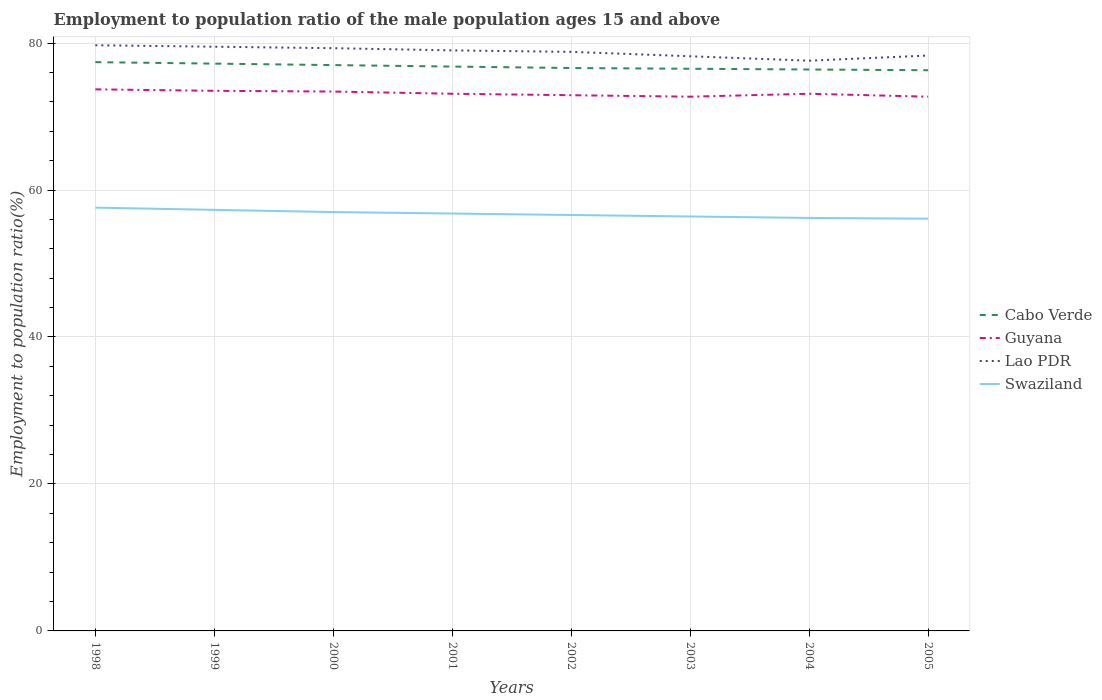Does the line corresponding to Lao PDR intersect with the line corresponding to Swaziland?
Offer a terse response. No. Across all years, what is the maximum employment to population ratio in Guyana?
Your response must be concise. 72.7. What is the total employment to population ratio in Swaziland in the graph?
Your answer should be very brief. 0.8. What is the difference between the highest and the second highest employment to population ratio in Cabo Verde?
Give a very brief answer. 1.1. How many lines are there?
Offer a terse response. 4. What is the difference between two consecutive major ticks on the Y-axis?
Your answer should be compact. 20. Are the values on the major ticks of Y-axis written in scientific E-notation?
Offer a terse response. No. Does the graph contain grids?
Provide a short and direct response. Yes. Where does the legend appear in the graph?
Ensure brevity in your answer.  Center right. How are the legend labels stacked?
Make the answer very short. Vertical. What is the title of the graph?
Offer a very short reply. Employment to population ratio of the male population ages 15 and above. Does "Liechtenstein" appear as one of the legend labels in the graph?
Provide a succinct answer. No. What is the label or title of the X-axis?
Provide a succinct answer. Years. What is the label or title of the Y-axis?
Provide a short and direct response. Employment to population ratio(%). What is the Employment to population ratio(%) in Cabo Verde in 1998?
Provide a short and direct response. 77.4. What is the Employment to population ratio(%) of Guyana in 1998?
Keep it short and to the point. 73.7. What is the Employment to population ratio(%) in Lao PDR in 1998?
Offer a terse response. 79.7. What is the Employment to population ratio(%) in Swaziland in 1998?
Your answer should be very brief. 57.6. What is the Employment to population ratio(%) of Cabo Verde in 1999?
Ensure brevity in your answer.  77.2. What is the Employment to population ratio(%) in Guyana in 1999?
Make the answer very short. 73.5. What is the Employment to population ratio(%) of Lao PDR in 1999?
Your answer should be very brief. 79.5. What is the Employment to population ratio(%) in Swaziland in 1999?
Your response must be concise. 57.3. What is the Employment to population ratio(%) in Cabo Verde in 2000?
Provide a succinct answer. 77. What is the Employment to population ratio(%) in Guyana in 2000?
Your answer should be very brief. 73.4. What is the Employment to population ratio(%) in Lao PDR in 2000?
Provide a succinct answer. 79.3. What is the Employment to population ratio(%) of Cabo Verde in 2001?
Your response must be concise. 76.8. What is the Employment to population ratio(%) of Guyana in 2001?
Keep it short and to the point. 73.1. What is the Employment to population ratio(%) in Lao PDR in 2001?
Your answer should be compact. 79. What is the Employment to population ratio(%) in Swaziland in 2001?
Your answer should be very brief. 56.8. What is the Employment to population ratio(%) in Cabo Verde in 2002?
Keep it short and to the point. 76.6. What is the Employment to population ratio(%) of Guyana in 2002?
Offer a terse response. 72.9. What is the Employment to population ratio(%) of Lao PDR in 2002?
Keep it short and to the point. 78.8. What is the Employment to population ratio(%) in Swaziland in 2002?
Provide a succinct answer. 56.6. What is the Employment to population ratio(%) in Cabo Verde in 2003?
Make the answer very short. 76.5. What is the Employment to population ratio(%) in Guyana in 2003?
Ensure brevity in your answer.  72.7. What is the Employment to population ratio(%) in Lao PDR in 2003?
Your answer should be compact. 78.2. What is the Employment to population ratio(%) of Swaziland in 2003?
Your response must be concise. 56.4. What is the Employment to population ratio(%) of Cabo Verde in 2004?
Offer a terse response. 76.4. What is the Employment to population ratio(%) of Guyana in 2004?
Offer a terse response. 73.1. What is the Employment to population ratio(%) of Lao PDR in 2004?
Offer a very short reply. 77.6. What is the Employment to population ratio(%) in Swaziland in 2004?
Your answer should be very brief. 56.2. What is the Employment to population ratio(%) of Cabo Verde in 2005?
Give a very brief answer. 76.3. What is the Employment to population ratio(%) in Guyana in 2005?
Make the answer very short. 72.7. What is the Employment to population ratio(%) of Lao PDR in 2005?
Provide a short and direct response. 78.3. What is the Employment to population ratio(%) in Swaziland in 2005?
Provide a succinct answer. 56.1. Across all years, what is the maximum Employment to population ratio(%) of Cabo Verde?
Offer a terse response. 77.4. Across all years, what is the maximum Employment to population ratio(%) of Guyana?
Ensure brevity in your answer.  73.7. Across all years, what is the maximum Employment to population ratio(%) of Lao PDR?
Provide a short and direct response. 79.7. Across all years, what is the maximum Employment to population ratio(%) in Swaziland?
Provide a short and direct response. 57.6. Across all years, what is the minimum Employment to population ratio(%) in Cabo Verde?
Offer a terse response. 76.3. Across all years, what is the minimum Employment to population ratio(%) in Guyana?
Keep it short and to the point. 72.7. Across all years, what is the minimum Employment to population ratio(%) in Lao PDR?
Ensure brevity in your answer.  77.6. Across all years, what is the minimum Employment to population ratio(%) in Swaziland?
Your response must be concise. 56.1. What is the total Employment to population ratio(%) of Cabo Verde in the graph?
Offer a very short reply. 614.2. What is the total Employment to population ratio(%) in Guyana in the graph?
Provide a succinct answer. 585.1. What is the total Employment to population ratio(%) of Lao PDR in the graph?
Provide a succinct answer. 630.4. What is the total Employment to population ratio(%) of Swaziland in the graph?
Provide a short and direct response. 454. What is the difference between the Employment to population ratio(%) of Cabo Verde in 1998 and that in 1999?
Your answer should be compact. 0.2. What is the difference between the Employment to population ratio(%) of Guyana in 1998 and that in 1999?
Offer a terse response. 0.2. What is the difference between the Employment to population ratio(%) in Lao PDR in 1998 and that in 1999?
Make the answer very short. 0.2. What is the difference between the Employment to population ratio(%) of Lao PDR in 1998 and that in 2000?
Offer a terse response. 0.4. What is the difference between the Employment to population ratio(%) in Swaziland in 1998 and that in 2000?
Provide a short and direct response. 0.6. What is the difference between the Employment to population ratio(%) in Swaziland in 1998 and that in 2002?
Keep it short and to the point. 1. What is the difference between the Employment to population ratio(%) of Guyana in 1998 and that in 2003?
Give a very brief answer. 1. What is the difference between the Employment to population ratio(%) in Guyana in 1998 and that in 2004?
Ensure brevity in your answer.  0.6. What is the difference between the Employment to population ratio(%) of Lao PDR in 1998 and that in 2004?
Your answer should be very brief. 2.1. What is the difference between the Employment to population ratio(%) in Cabo Verde in 1998 and that in 2005?
Offer a terse response. 1.1. What is the difference between the Employment to population ratio(%) of Guyana in 1998 and that in 2005?
Make the answer very short. 1. What is the difference between the Employment to population ratio(%) in Lao PDR in 1998 and that in 2005?
Your answer should be very brief. 1.4. What is the difference between the Employment to population ratio(%) in Swaziland in 1998 and that in 2005?
Offer a very short reply. 1.5. What is the difference between the Employment to population ratio(%) of Cabo Verde in 1999 and that in 2000?
Provide a short and direct response. 0.2. What is the difference between the Employment to population ratio(%) in Lao PDR in 1999 and that in 2000?
Your answer should be very brief. 0.2. What is the difference between the Employment to population ratio(%) in Cabo Verde in 1999 and that in 2001?
Make the answer very short. 0.4. What is the difference between the Employment to population ratio(%) in Cabo Verde in 1999 and that in 2003?
Ensure brevity in your answer.  0.7. What is the difference between the Employment to population ratio(%) of Lao PDR in 1999 and that in 2004?
Offer a very short reply. 1.9. What is the difference between the Employment to population ratio(%) of Swaziland in 1999 and that in 2004?
Provide a succinct answer. 1.1. What is the difference between the Employment to population ratio(%) of Guyana in 1999 and that in 2005?
Ensure brevity in your answer.  0.8. What is the difference between the Employment to population ratio(%) of Lao PDR in 1999 and that in 2005?
Provide a short and direct response. 1.2. What is the difference between the Employment to population ratio(%) in Swaziland in 1999 and that in 2005?
Keep it short and to the point. 1.2. What is the difference between the Employment to population ratio(%) in Cabo Verde in 2000 and that in 2001?
Your answer should be very brief. 0.2. What is the difference between the Employment to population ratio(%) in Cabo Verde in 2000 and that in 2002?
Keep it short and to the point. 0.4. What is the difference between the Employment to population ratio(%) in Swaziland in 2000 and that in 2002?
Keep it short and to the point. 0.4. What is the difference between the Employment to population ratio(%) of Guyana in 2000 and that in 2003?
Give a very brief answer. 0.7. What is the difference between the Employment to population ratio(%) in Cabo Verde in 2000 and that in 2004?
Provide a short and direct response. 0.6. What is the difference between the Employment to population ratio(%) of Guyana in 2000 and that in 2004?
Your answer should be very brief. 0.3. What is the difference between the Employment to population ratio(%) in Swaziland in 2000 and that in 2004?
Your answer should be very brief. 0.8. What is the difference between the Employment to population ratio(%) of Cabo Verde in 2000 and that in 2005?
Your answer should be very brief. 0.7. What is the difference between the Employment to population ratio(%) of Guyana in 2000 and that in 2005?
Offer a terse response. 0.7. What is the difference between the Employment to population ratio(%) of Swaziland in 2000 and that in 2005?
Ensure brevity in your answer.  0.9. What is the difference between the Employment to population ratio(%) of Guyana in 2001 and that in 2002?
Keep it short and to the point. 0.2. What is the difference between the Employment to population ratio(%) of Cabo Verde in 2001 and that in 2003?
Offer a terse response. 0.3. What is the difference between the Employment to population ratio(%) of Guyana in 2001 and that in 2003?
Keep it short and to the point. 0.4. What is the difference between the Employment to population ratio(%) of Lao PDR in 2001 and that in 2003?
Ensure brevity in your answer.  0.8. What is the difference between the Employment to population ratio(%) in Swaziland in 2001 and that in 2003?
Provide a short and direct response. 0.4. What is the difference between the Employment to population ratio(%) of Cabo Verde in 2001 and that in 2004?
Give a very brief answer. 0.4. What is the difference between the Employment to population ratio(%) of Cabo Verde in 2001 and that in 2005?
Provide a short and direct response. 0.5. What is the difference between the Employment to population ratio(%) in Cabo Verde in 2002 and that in 2003?
Make the answer very short. 0.1. What is the difference between the Employment to population ratio(%) in Guyana in 2002 and that in 2003?
Provide a succinct answer. 0.2. What is the difference between the Employment to population ratio(%) in Swaziland in 2002 and that in 2003?
Your answer should be compact. 0.2. What is the difference between the Employment to population ratio(%) in Cabo Verde in 2002 and that in 2005?
Your response must be concise. 0.3. What is the difference between the Employment to population ratio(%) of Lao PDR in 2002 and that in 2005?
Provide a short and direct response. 0.5. What is the difference between the Employment to population ratio(%) in Guyana in 2003 and that in 2004?
Make the answer very short. -0.4. What is the difference between the Employment to population ratio(%) of Lao PDR in 2003 and that in 2004?
Offer a very short reply. 0.6. What is the difference between the Employment to population ratio(%) in Guyana in 2003 and that in 2005?
Make the answer very short. 0. What is the difference between the Employment to population ratio(%) of Guyana in 2004 and that in 2005?
Keep it short and to the point. 0.4. What is the difference between the Employment to population ratio(%) of Swaziland in 2004 and that in 2005?
Your response must be concise. 0.1. What is the difference between the Employment to population ratio(%) in Cabo Verde in 1998 and the Employment to population ratio(%) in Swaziland in 1999?
Provide a succinct answer. 20.1. What is the difference between the Employment to population ratio(%) in Guyana in 1998 and the Employment to population ratio(%) in Lao PDR in 1999?
Give a very brief answer. -5.8. What is the difference between the Employment to population ratio(%) in Lao PDR in 1998 and the Employment to population ratio(%) in Swaziland in 1999?
Your response must be concise. 22.4. What is the difference between the Employment to population ratio(%) of Cabo Verde in 1998 and the Employment to population ratio(%) of Guyana in 2000?
Offer a very short reply. 4. What is the difference between the Employment to population ratio(%) in Cabo Verde in 1998 and the Employment to population ratio(%) in Swaziland in 2000?
Provide a short and direct response. 20.4. What is the difference between the Employment to population ratio(%) of Guyana in 1998 and the Employment to population ratio(%) of Swaziland in 2000?
Your answer should be compact. 16.7. What is the difference between the Employment to population ratio(%) of Lao PDR in 1998 and the Employment to population ratio(%) of Swaziland in 2000?
Make the answer very short. 22.7. What is the difference between the Employment to population ratio(%) in Cabo Verde in 1998 and the Employment to population ratio(%) in Guyana in 2001?
Offer a terse response. 4.3. What is the difference between the Employment to population ratio(%) of Cabo Verde in 1998 and the Employment to population ratio(%) of Swaziland in 2001?
Ensure brevity in your answer.  20.6. What is the difference between the Employment to population ratio(%) of Guyana in 1998 and the Employment to population ratio(%) of Lao PDR in 2001?
Offer a very short reply. -5.3. What is the difference between the Employment to population ratio(%) of Lao PDR in 1998 and the Employment to population ratio(%) of Swaziland in 2001?
Provide a short and direct response. 22.9. What is the difference between the Employment to population ratio(%) of Cabo Verde in 1998 and the Employment to population ratio(%) of Guyana in 2002?
Provide a short and direct response. 4.5. What is the difference between the Employment to population ratio(%) in Cabo Verde in 1998 and the Employment to population ratio(%) in Swaziland in 2002?
Your response must be concise. 20.8. What is the difference between the Employment to population ratio(%) of Lao PDR in 1998 and the Employment to population ratio(%) of Swaziland in 2002?
Provide a short and direct response. 23.1. What is the difference between the Employment to population ratio(%) in Cabo Verde in 1998 and the Employment to population ratio(%) in Guyana in 2003?
Make the answer very short. 4.7. What is the difference between the Employment to population ratio(%) in Cabo Verde in 1998 and the Employment to population ratio(%) in Lao PDR in 2003?
Provide a short and direct response. -0.8. What is the difference between the Employment to population ratio(%) of Cabo Verde in 1998 and the Employment to population ratio(%) of Swaziland in 2003?
Provide a short and direct response. 21. What is the difference between the Employment to population ratio(%) in Guyana in 1998 and the Employment to population ratio(%) in Lao PDR in 2003?
Give a very brief answer. -4.5. What is the difference between the Employment to population ratio(%) in Guyana in 1998 and the Employment to population ratio(%) in Swaziland in 2003?
Keep it short and to the point. 17.3. What is the difference between the Employment to population ratio(%) of Lao PDR in 1998 and the Employment to population ratio(%) of Swaziland in 2003?
Ensure brevity in your answer.  23.3. What is the difference between the Employment to population ratio(%) of Cabo Verde in 1998 and the Employment to population ratio(%) of Lao PDR in 2004?
Offer a terse response. -0.2. What is the difference between the Employment to population ratio(%) of Cabo Verde in 1998 and the Employment to population ratio(%) of Swaziland in 2004?
Your answer should be compact. 21.2. What is the difference between the Employment to population ratio(%) of Guyana in 1998 and the Employment to population ratio(%) of Lao PDR in 2004?
Provide a short and direct response. -3.9. What is the difference between the Employment to population ratio(%) in Guyana in 1998 and the Employment to population ratio(%) in Swaziland in 2004?
Provide a succinct answer. 17.5. What is the difference between the Employment to population ratio(%) in Cabo Verde in 1998 and the Employment to population ratio(%) in Guyana in 2005?
Your answer should be compact. 4.7. What is the difference between the Employment to population ratio(%) of Cabo Verde in 1998 and the Employment to population ratio(%) of Lao PDR in 2005?
Offer a terse response. -0.9. What is the difference between the Employment to population ratio(%) of Cabo Verde in 1998 and the Employment to population ratio(%) of Swaziland in 2005?
Your answer should be very brief. 21.3. What is the difference between the Employment to population ratio(%) in Lao PDR in 1998 and the Employment to population ratio(%) in Swaziland in 2005?
Your answer should be very brief. 23.6. What is the difference between the Employment to population ratio(%) of Cabo Verde in 1999 and the Employment to population ratio(%) of Guyana in 2000?
Give a very brief answer. 3.8. What is the difference between the Employment to population ratio(%) in Cabo Verde in 1999 and the Employment to population ratio(%) in Lao PDR in 2000?
Keep it short and to the point. -2.1. What is the difference between the Employment to population ratio(%) of Cabo Verde in 1999 and the Employment to population ratio(%) of Swaziland in 2000?
Offer a very short reply. 20.2. What is the difference between the Employment to population ratio(%) of Guyana in 1999 and the Employment to population ratio(%) of Swaziland in 2000?
Your response must be concise. 16.5. What is the difference between the Employment to population ratio(%) in Lao PDR in 1999 and the Employment to population ratio(%) in Swaziland in 2000?
Offer a very short reply. 22.5. What is the difference between the Employment to population ratio(%) of Cabo Verde in 1999 and the Employment to population ratio(%) of Swaziland in 2001?
Give a very brief answer. 20.4. What is the difference between the Employment to population ratio(%) in Guyana in 1999 and the Employment to population ratio(%) in Lao PDR in 2001?
Keep it short and to the point. -5.5. What is the difference between the Employment to population ratio(%) in Lao PDR in 1999 and the Employment to population ratio(%) in Swaziland in 2001?
Provide a succinct answer. 22.7. What is the difference between the Employment to population ratio(%) of Cabo Verde in 1999 and the Employment to population ratio(%) of Guyana in 2002?
Keep it short and to the point. 4.3. What is the difference between the Employment to population ratio(%) of Cabo Verde in 1999 and the Employment to population ratio(%) of Swaziland in 2002?
Offer a terse response. 20.6. What is the difference between the Employment to population ratio(%) of Guyana in 1999 and the Employment to population ratio(%) of Lao PDR in 2002?
Provide a short and direct response. -5.3. What is the difference between the Employment to population ratio(%) in Lao PDR in 1999 and the Employment to population ratio(%) in Swaziland in 2002?
Give a very brief answer. 22.9. What is the difference between the Employment to population ratio(%) in Cabo Verde in 1999 and the Employment to population ratio(%) in Swaziland in 2003?
Your answer should be very brief. 20.8. What is the difference between the Employment to population ratio(%) of Guyana in 1999 and the Employment to population ratio(%) of Swaziland in 2003?
Keep it short and to the point. 17.1. What is the difference between the Employment to population ratio(%) of Lao PDR in 1999 and the Employment to population ratio(%) of Swaziland in 2003?
Offer a terse response. 23.1. What is the difference between the Employment to population ratio(%) in Cabo Verde in 1999 and the Employment to population ratio(%) in Guyana in 2004?
Your answer should be very brief. 4.1. What is the difference between the Employment to population ratio(%) of Guyana in 1999 and the Employment to population ratio(%) of Swaziland in 2004?
Offer a very short reply. 17.3. What is the difference between the Employment to population ratio(%) in Lao PDR in 1999 and the Employment to population ratio(%) in Swaziland in 2004?
Your answer should be compact. 23.3. What is the difference between the Employment to population ratio(%) in Cabo Verde in 1999 and the Employment to population ratio(%) in Swaziland in 2005?
Your answer should be compact. 21.1. What is the difference between the Employment to population ratio(%) in Guyana in 1999 and the Employment to population ratio(%) in Lao PDR in 2005?
Keep it short and to the point. -4.8. What is the difference between the Employment to population ratio(%) of Guyana in 1999 and the Employment to population ratio(%) of Swaziland in 2005?
Your answer should be compact. 17.4. What is the difference between the Employment to population ratio(%) of Lao PDR in 1999 and the Employment to population ratio(%) of Swaziland in 2005?
Give a very brief answer. 23.4. What is the difference between the Employment to population ratio(%) of Cabo Verde in 2000 and the Employment to population ratio(%) of Guyana in 2001?
Offer a very short reply. 3.9. What is the difference between the Employment to population ratio(%) in Cabo Verde in 2000 and the Employment to population ratio(%) in Lao PDR in 2001?
Keep it short and to the point. -2. What is the difference between the Employment to population ratio(%) in Cabo Verde in 2000 and the Employment to population ratio(%) in Swaziland in 2001?
Give a very brief answer. 20.2. What is the difference between the Employment to population ratio(%) in Lao PDR in 2000 and the Employment to population ratio(%) in Swaziland in 2001?
Offer a terse response. 22.5. What is the difference between the Employment to population ratio(%) of Cabo Verde in 2000 and the Employment to population ratio(%) of Guyana in 2002?
Offer a terse response. 4.1. What is the difference between the Employment to population ratio(%) in Cabo Verde in 2000 and the Employment to population ratio(%) in Swaziland in 2002?
Give a very brief answer. 20.4. What is the difference between the Employment to population ratio(%) in Lao PDR in 2000 and the Employment to population ratio(%) in Swaziland in 2002?
Your answer should be compact. 22.7. What is the difference between the Employment to population ratio(%) in Cabo Verde in 2000 and the Employment to population ratio(%) in Swaziland in 2003?
Your response must be concise. 20.6. What is the difference between the Employment to population ratio(%) of Guyana in 2000 and the Employment to population ratio(%) of Lao PDR in 2003?
Offer a very short reply. -4.8. What is the difference between the Employment to population ratio(%) of Guyana in 2000 and the Employment to population ratio(%) of Swaziland in 2003?
Your answer should be very brief. 17. What is the difference between the Employment to population ratio(%) in Lao PDR in 2000 and the Employment to population ratio(%) in Swaziland in 2003?
Keep it short and to the point. 22.9. What is the difference between the Employment to population ratio(%) of Cabo Verde in 2000 and the Employment to population ratio(%) of Guyana in 2004?
Make the answer very short. 3.9. What is the difference between the Employment to population ratio(%) in Cabo Verde in 2000 and the Employment to population ratio(%) in Swaziland in 2004?
Your answer should be compact. 20.8. What is the difference between the Employment to population ratio(%) in Guyana in 2000 and the Employment to population ratio(%) in Lao PDR in 2004?
Ensure brevity in your answer.  -4.2. What is the difference between the Employment to population ratio(%) of Guyana in 2000 and the Employment to population ratio(%) of Swaziland in 2004?
Provide a short and direct response. 17.2. What is the difference between the Employment to population ratio(%) of Lao PDR in 2000 and the Employment to population ratio(%) of Swaziland in 2004?
Offer a terse response. 23.1. What is the difference between the Employment to population ratio(%) in Cabo Verde in 2000 and the Employment to population ratio(%) in Guyana in 2005?
Offer a terse response. 4.3. What is the difference between the Employment to population ratio(%) of Cabo Verde in 2000 and the Employment to population ratio(%) of Lao PDR in 2005?
Ensure brevity in your answer.  -1.3. What is the difference between the Employment to population ratio(%) of Cabo Verde in 2000 and the Employment to population ratio(%) of Swaziland in 2005?
Offer a very short reply. 20.9. What is the difference between the Employment to population ratio(%) in Guyana in 2000 and the Employment to population ratio(%) in Lao PDR in 2005?
Ensure brevity in your answer.  -4.9. What is the difference between the Employment to population ratio(%) of Guyana in 2000 and the Employment to population ratio(%) of Swaziland in 2005?
Offer a very short reply. 17.3. What is the difference between the Employment to population ratio(%) of Lao PDR in 2000 and the Employment to population ratio(%) of Swaziland in 2005?
Offer a terse response. 23.2. What is the difference between the Employment to population ratio(%) of Cabo Verde in 2001 and the Employment to population ratio(%) of Guyana in 2002?
Offer a very short reply. 3.9. What is the difference between the Employment to population ratio(%) of Cabo Verde in 2001 and the Employment to population ratio(%) of Lao PDR in 2002?
Your answer should be compact. -2. What is the difference between the Employment to population ratio(%) in Cabo Verde in 2001 and the Employment to population ratio(%) in Swaziland in 2002?
Provide a succinct answer. 20.2. What is the difference between the Employment to population ratio(%) in Lao PDR in 2001 and the Employment to population ratio(%) in Swaziland in 2002?
Give a very brief answer. 22.4. What is the difference between the Employment to population ratio(%) of Cabo Verde in 2001 and the Employment to population ratio(%) of Guyana in 2003?
Give a very brief answer. 4.1. What is the difference between the Employment to population ratio(%) of Cabo Verde in 2001 and the Employment to population ratio(%) of Swaziland in 2003?
Give a very brief answer. 20.4. What is the difference between the Employment to population ratio(%) of Guyana in 2001 and the Employment to population ratio(%) of Swaziland in 2003?
Make the answer very short. 16.7. What is the difference between the Employment to population ratio(%) of Lao PDR in 2001 and the Employment to population ratio(%) of Swaziland in 2003?
Give a very brief answer. 22.6. What is the difference between the Employment to population ratio(%) in Cabo Verde in 2001 and the Employment to population ratio(%) in Lao PDR in 2004?
Offer a very short reply. -0.8. What is the difference between the Employment to population ratio(%) in Cabo Verde in 2001 and the Employment to population ratio(%) in Swaziland in 2004?
Your answer should be very brief. 20.6. What is the difference between the Employment to population ratio(%) of Guyana in 2001 and the Employment to population ratio(%) of Lao PDR in 2004?
Provide a succinct answer. -4.5. What is the difference between the Employment to population ratio(%) of Guyana in 2001 and the Employment to population ratio(%) of Swaziland in 2004?
Your answer should be very brief. 16.9. What is the difference between the Employment to population ratio(%) of Lao PDR in 2001 and the Employment to population ratio(%) of Swaziland in 2004?
Offer a terse response. 22.8. What is the difference between the Employment to population ratio(%) of Cabo Verde in 2001 and the Employment to population ratio(%) of Guyana in 2005?
Make the answer very short. 4.1. What is the difference between the Employment to population ratio(%) of Cabo Verde in 2001 and the Employment to population ratio(%) of Swaziland in 2005?
Provide a succinct answer. 20.7. What is the difference between the Employment to population ratio(%) of Lao PDR in 2001 and the Employment to population ratio(%) of Swaziland in 2005?
Give a very brief answer. 22.9. What is the difference between the Employment to population ratio(%) of Cabo Verde in 2002 and the Employment to population ratio(%) of Swaziland in 2003?
Offer a terse response. 20.2. What is the difference between the Employment to population ratio(%) of Guyana in 2002 and the Employment to population ratio(%) of Lao PDR in 2003?
Offer a very short reply. -5.3. What is the difference between the Employment to population ratio(%) in Guyana in 2002 and the Employment to population ratio(%) in Swaziland in 2003?
Your response must be concise. 16.5. What is the difference between the Employment to population ratio(%) in Lao PDR in 2002 and the Employment to population ratio(%) in Swaziland in 2003?
Your response must be concise. 22.4. What is the difference between the Employment to population ratio(%) in Cabo Verde in 2002 and the Employment to population ratio(%) in Lao PDR in 2004?
Your answer should be compact. -1. What is the difference between the Employment to population ratio(%) in Cabo Verde in 2002 and the Employment to population ratio(%) in Swaziland in 2004?
Your answer should be very brief. 20.4. What is the difference between the Employment to population ratio(%) in Guyana in 2002 and the Employment to population ratio(%) in Swaziland in 2004?
Provide a short and direct response. 16.7. What is the difference between the Employment to population ratio(%) in Lao PDR in 2002 and the Employment to population ratio(%) in Swaziland in 2004?
Ensure brevity in your answer.  22.6. What is the difference between the Employment to population ratio(%) of Cabo Verde in 2002 and the Employment to population ratio(%) of Guyana in 2005?
Your answer should be compact. 3.9. What is the difference between the Employment to population ratio(%) in Cabo Verde in 2002 and the Employment to population ratio(%) in Lao PDR in 2005?
Your response must be concise. -1.7. What is the difference between the Employment to population ratio(%) in Cabo Verde in 2002 and the Employment to population ratio(%) in Swaziland in 2005?
Ensure brevity in your answer.  20.5. What is the difference between the Employment to population ratio(%) in Lao PDR in 2002 and the Employment to population ratio(%) in Swaziland in 2005?
Keep it short and to the point. 22.7. What is the difference between the Employment to population ratio(%) in Cabo Verde in 2003 and the Employment to population ratio(%) in Guyana in 2004?
Offer a very short reply. 3.4. What is the difference between the Employment to population ratio(%) in Cabo Verde in 2003 and the Employment to population ratio(%) in Lao PDR in 2004?
Ensure brevity in your answer.  -1.1. What is the difference between the Employment to population ratio(%) of Cabo Verde in 2003 and the Employment to population ratio(%) of Swaziland in 2004?
Give a very brief answer. 20.3. What is the difference between the Employment to population ratio(%) in Guyana in 2003 and the Employment to population ratio(%) in Lao PDR in 2004?
Keep it short and to the point. -4.9. What is the difference between the Employment to population ratio(%) in Guyana in 2003 and the Employment to population ratio(%) in Swaziland in 2004?
Keep it short and to the point. 16.5. What is the difference between the Employment to population ratio(%) of Lao PDR in 2003 and the Employment to population ratio(%) of Swaziland in 2004?
Provide a succinct answer. 22. What is the difference between the Employment to population ratio(%) of Cabo Verde in 2003 and the Employment to population ratio(%) of Guyana in 2005?
Provide a short and direct response. 3.8. What is the difference between the Employment to population ratio(%) in Cabo Verde in 2003 and the Employment to population ratio(%) in Lao PDR in 2005?
Provide a succinct answer. -1.8. What is the difference between the Employment to population ratio(%) in Cabo Verde in 2003 and the Employment to population ratio(%) in Swaziland in 2005?
Make the answer very short. 20.4. What is the difference between the Employment to population ratio(%) in Lao PDR in 2003 and the Employment to population ratio(%) in Swaziland in 2005?
Your answer should be compact. 22.1. What is the difference between the Employment to population ratio(%) of Cabo Verde in 2004 and the Employment to population ratio(%) of Swaziland in 2005?
Make the answer very short. 20.3. What is the difference between the Employment to population ratio(%) in Lao PDR in 2004 and the Employment to population ratio(%) in Swaziland in 2005?
Provide a short and direct response. 21.5. What is the average Employment to population ratio(%) in Cabo Verde per year?
Offer a terse response. 76.78. What is the average Employment to population ratio(%) in Guyana per year?
Offer a terse response. 73.14. What is the average Employment to population ratio(%) in Lao PDR per year?
Give a very brief answer. 78.8. What is the average Employment to population ratio(%) of Swaziland per year?
Give a very brief answer. 56.75. In the year 1998, what is the difference between the Employment to population ratio(%) in Cabo Verde and Employment to population ratio(%) in Lao PDR?
Your answer should be very brief. -2.3. In the year 1998, what is the difference between the Employment to population ratio(%) of Cabo Verde and Employment to population ratio(%) of Swaziland?
Make the answer very short. 19.8. In the year 1998, what is the difference between the Employment to population ratio(%) in Guyana and Employment to population ratio(%) in Lao PDR?
Keep it short and to the point. -6. In the year 1998, what is the difference between the Employment to population ratio(%) in Guyana and Employment to population ratio(%) in Swaziland?
Offer a very short reply. 16.1. In the year 1998, what is the difference between the Employment to population ratio(%) of Lao PDR and Employment to population ratio(%) of Swaziland?
Provide a succinct answer. 22.1. In the year 1999, what is the difference between the Employment to population ratio(%) of Cabo Verde and Employment to population ratio(%) of Lao PDR?
Ensure brevity in your answer.  -2.3. In the year 1999, what is the difference between the Employment to population ratio(%) in Cabo Verde and Employment to population ratio(%) in Swaziland?
Provide a succinct answer. 19.9. In the year 1999, what is the difference between the Employment to population ratio(%) of Guyana and Employment to population ratio(%) of Swaziland?
Provide a succinct answer. 16.2. In the year 1999, what is the difference between the Employment to population ratio(%) of Lao PDR and Employment to population ratio(%) of Swaziland?
Offer a terse response. 22.2. In the year 2000, what is the difference between the Employment to population ratio(%) in Cabo Verde and Employment to population ratio(%) in Swaziland?
Give a very brief answer. 20. In the year 2000, what is the difference between the Employment to population ratio(%) of Guyana and Employment to population ratio(%) of Lao PDR?
Offer a terse response. -5.9. In the year 2000, what is the difference between the Employment to population ratio(%) of Guyana and Employment to population ratio(%) of Swaziland?
Give a very brief answer. 16.4. In the year 2000, what is the difference between the Employment to population ratio(%) in Lao PDR and Employment to population ratio(%) in Swaziland?
Offer a very short reply. 22.3. In the year 2001, what is the difference between the Employment to population ratio(%) of Cabo Verde and Employment to population ratio(%) of Guyana?
Offer a terse response. 3.7. In the year 2001, what is the difference between the Employment to population ratio(%) in Cabo Verde and Employment to population ratio(%) in Lao PDR?
Your answer should be very brief. -2.2. In the year 2001, what is the difference between the Employment to population ratio(%) in Cabo Verde and Employment to population ratio(%) in Swaziland?
Keep it short and to the point. 20. In the year 2001, what is the difference between the Employment to population ratio(%) of Guyana and Employment to population ratio(%) of Lao PDR?
Provide a short and direct response. -5.9. In the year 2002, what is the difference between the Employment to population ratio(%) in Cabo Verde and Employment to population ratio(%) in Guyana?
Give a very brief answer. 3.7. In the year 2002, what is the difference between the Employment to population ratio(%) in Cabo Verde and Employment to population ratio(%) in Swaziland?
Provide a short and direct response. 20. In the year 2002, what is the difference between the Employment to population ratio(%) of Guyana and Employment to population ratio(%) of Lao PDR?
Make the answer very short. -5.9. In the year 2002, what is the difference between the Employment to population ratio(%) of Guyana and Employment to population ratio(%) of Swaziland?
Make the answer very short. 16.3. In the year 2002, what is the difference between the Employment to population ratio(%) of Lao PDR and Employment to population ratio(%) of Swaziland?
Make the answer very short. 22.2. In the year 2003, what is the difference between the Employment to population ratio(%) of Cabo Verde and Employment to population ratio(%) of Guyana?
Make the answer very short. 3.8. In the year 2003, what is the difference between the Employment to population ratio(%) in Cabo Verde and Employment to population ratio(%) in Swaziland?
Offer a very short reply. 20.1. In the year 2003, what is the difference between the Employment to population ratio(%) in Lao PDR and Employment to population ratio(%) in Swaziland?
Your answer should be very brief. 21.8. In the year 2004, what is the difference between the Employment to population ratio(%) in Cabo Verde and Employment to population ratio(%) in Guyana?
Ensure brevity in your answer.  3.3. In the year 2004, what is the difference between the Employment to population ratio(%) of Cabo Verde and Employment to population ratio(%) of Swaziland?
Provide a succinct answer. 20.2. In the year 2004, what is the difference between the Employment to population ratio(%) in Guyana and Employment to population ratio(%) in Lao PDR?
Provide a short and direct response. -4.5. In the year 2004, what is the difference between the Employment to population ratio(%) of Lao PDR and Employment to population ratio(%) of Swaziland?
Your response must be concise. 21.4. In the year 2005, what is the difference between the Employment to population ratio(%) in Cabo Verde and Employment to population ratio(%) in Guyana?
Make the answer very short. 3.6. In the year 2005, what is the difference between the Employment to population ratio(%) in Cabo Verde and Employment to population ratio(%) in Swaziland?
Give a very brief answer. 20.2. In the year 2005, what is the difference between the Employment to population ratio(%) of Guyana and Employment to population ratio(%) of Lao PDR?
Your answer should be compact. -5.6. In the year 2005, what is the difference between the Employment to population ratio(%) of Lao PDR and Employment to population ratio(%) of Swaziland?
Your answer should be very brief. 22.2. What is the ratio of the Employment to population ratio(%) of Cabo Verde in 1998 to that in 1999?
Offer a terse response. 1. What is the ratio of the Employment to population ratio(%) in Guyana in 1998 to that in 1999?
Ensure brevity in your answer.  1. What is the ratio of the Employment to population ratio(%) in Swaziland in 1998 to that in 1999?
Keep it short and to the point. 1.01. What is the ratio of the Employment to population ratio(%) in Cabo Verde in 1998 to that in 2000?
Your response must be concise. 1.01. What is the ratio of the Employment to population ratio(%) of Swaziland in 1998 to that in 2000?
Give a very brief answer. 1.01. What is the ratio of the Employment to population ratio(%) of Cabo Verde in 1998 to that in 2001?
Your answer should be very brief. 1.01. What is the ratio of the Employment to population ratio(%) of Guyana in 1998 to that in 2001?
Keep it short and to the point. 1.01. What is the ratio of the Employment to population ratio(%) in Lao PDR in 1998 to that in 2001?
Your answer should be compact. 1.01. What is the ratio of the Employment to population ratio(%) of Swaziland in 1998 to that in 2001?
Your answer should be very brief. 1.01. What is the ratio of the Employment to population ratio(%) in Cabo Verde in 1998 to that in 2002?
Provide a short and direct response. 1.01. What is the ratio of the Employment to population ratio(%) in Lao PDR in 1998 to that in 2002?
Give a very brief answer. 1.01. What is the ratio of the Employment to population ratio(%) in Swaziland in 1998 to that in 2002?
Offer a very short reply. 1.02. What is the ratio of the Employment to population ratio(%) of Cabo Verde in 1998 to that in 2003?
Make the answer very short. 1.01. What is the ratio of the Employment to population ratio(%) in Guyana in 1998 to that in 2003?
Provide a succinct answer. 1.01. What is the ratio of the Employment to population ratio(%) in Lao PDR in 1998 to that in 2003?
Make the answer very short. 1.02. What is the ratio of the Employment to population ratio(%) of Swaziland in 1998 to that in 2003?
Offer a very short reply. 1.02. What is the ratio of the Employment to population ratio(%) in Cabo Verde in 1998 to that in 2004?
Offer a terse response. 1.01. What is the ratio of the Employment to population ratio(%) of Guyana in 1998 to that in 2004?
Provide a short and direct response. 1.01. What is the ratio of the Employment to population ratio(%) of Lao PDR in 1998 to that in 2004?
Your response must be concise. 1.03. What is the ratio of the Employment to population ratio(%) in Swaziland in 1998 to that in 2004?
Provide a short and direct response. 1.02. What is the ratio of the Employment to population ratio(%) of Cabo Verde in 1998 to that in 2005?
Your response must be concise. 1.01. What is the ratio of the Employment to population ratio(%) of Guyana in 1998 to that in 2005?
Give a very brief answer. 1.01. What is the ratio of the Employment to population ratio(%) of Lao PDR in 1998 to that in 2005?
Offer a very short reply. 1.02. What is the ratio of the Employment to population ratio(%) in Swaziland in 1998 to that in 2005?
Offer a very short reply. 1.03. What is the ratio of the Employment to population ratio(%) in Guyana in 1999 to that in 2000?
Your answer should be very brief. 1. What is the ratio of the Employment to population ratio(%) in Lao PDR in 1999 to that in 2000?
Ensure brevity in your answer.  1. What is the ratio of the Employment to population ratio(%) of Swaziland in 1999 to that in 2000?
Your response must be concise. 1.01. What is the ratio of the Employment to population ratio(%) in Cabo Verde in 1999 to that in 2001?
Provide a short and direct response. 1.01. What is the ratio of the Employment to population ratio(%) in Lao PDR in 1999 to that in 2001?
Your answer should be very brief. 1.01. What is the ratio of the Employment to population ratio(%) of Swaziland in 1999 to that in 2001?
Make the answer very short. 1.01. What is the ratio of the Employment to population ratio(%) of Guyana in 1999 to that in 2002?
Your answer should be compact. 1.01. What is the ratio of the Employment to population ratio(%) of Lao PDR in 1999 to that in 2002?
Offer a very short reply. 1.01. What is the ratio of the Employment to population ratio(%) in Swaziland in 1999 to that in 2002?
Give a very brief answer. 1.01. What is the ratio of the Employment to population ratio(%) of Cabo Verde in 1999 to that in 2003?
Offer a very short reply. 1.01. What is the ratio of the Employment to population ratio(%) of Guyana in 1999 to that in 2003?
Your answer should be compact. 1.01. What is the ratio of the Employment to population ratio(%) of Lao PDR in 1999 to that in 2003?
Provide a succinct answer. 1.02. What is the ratio of the Employment to population ratio(%) of Swaziland in 1999 to that in 2003?
Provide a short and direct response. 1.02. What is the ratio of the Employment to population ratio(%) in Cabo Verde in 1999 to that in 2004?
Ensure brevity in your answer.  1.01. What is the ratio of the Employment to population ratio(%) in Lao PDR in 1999 to that in 2004?
Ensure brevity in your answer.  1.02. What is the ratio of the Employment to population ratio(%) of Swaziland in 1999 to that in 2004?
Your response must be concise. 1.02. What is the ratio of the Employment to population ratio(%) of Cabo Verde in 1999 to that in 2005?
Provide a succinct answer. 1.01. What is the ratio of the Employment to population ratio(%) in Lao PDR in 1999 to that in 2005?
Offer a very short reply. 1.02. What is the ratio of the Employment to population ratio(%) in Swaziland in 1999 to that in 2005?
Your response must be concise. 1.02. What is the ratio of the Employment to population ratio(%) of Swaziland in 2000 to that in 2001?
Your answer should be compact. 1. What is the ratio of the Employment to population ratio(%) in Cabo Verde in 2000 to that in 2002?
Your answer should be very brief. 1.01. What is the ratio of the Employment to population ratio(%) in Lao PDR in 2000 to that in 2002?
Offer a terse response. 1.01. What is the ratio of the Employment to population ratio(%) of Swaziland in 2000 to that in 2002?
Your response must be concise. 1.01. What is the ratio of the Employment to population ratio(%) of Guyana in 2000 to that in 2003?
Your response must be concise. 1.01. What is the ratio of the Employment to population ratio(%) of Lao PDR in 2000 to that in 2003?
Offer a very short reply. 1.01. What is the ratio of the Employment to population ratio(%) in Swaziland in 2000 to that in 2003?
Your answer should be compact. 1.01. What is the ratio of the Employment to population ratio(%) in Cabo Verde in 2000 to that in 2004?
Offer a very short reply. 1.01. What is the ratio of the Employment to population ratio(%) of Guyana in 2000 to that in 2004?
Keep it short and to the point. 1. What is the ratio of the Employment to population ratio(%) in Lao PDR in 2000 to that in 2004?
Offer a terse response. 1.02. What is the ratio of the Employment to population ratio(%) of Swaziland in 2000 to that in 2004?
Give a very brief answer. 1.01. What is the ratio of the Employment to population ratio(%) in Cabo Verde in 2000 to that in 2005?
Offer a very short reply. 1.01. What is the ratio of the Employment to population ratio(%) of Guyana in 2000 to that in 2005?
Your response must be concise. 1.01. What is the ratio of the Employment to population ratio(%) of Lao PDR in 2000 to that in 2005?
Your response must be concise. 1.01. What is the ratio of the Employment to population ratio(%) in Guyana in 2001 to that in 2002?
Give a very brief answer. 1. What is the ratio of the Employment to population ratio(%) of Swaziland in 2001 to that in 2002?
Your response must be concise. 1. What is the ratio of the Employment to population ratio(%) of Lao PDR in 2001 to that in 2003?
Offer a very short reply. 1.01. What is the ratio of the Employment to population ratio(%) in Swaziland in 2001 to that in 2003?
Your response must be concise. 1.01. What is the ratio of the Employment to population ratio(%) of Lao PDR in 2001 to that in 2004?
Your answer should be compact. 1.02. What is the ratio of the Employment to population ratio(%) of Swaziland in 2001 to that in 2004?
Provide a succinct answer. 1.01. What is the ratio of the Employment to population ratio(%) in Cabo Verde in 2001 to that in 2005?
Ensure brevity in your answer.  1.01. What is the ratio of the Employment to population ratio(%) of Guyana in 2001 to that in 2005?
Keep it short and to the point. 1.01. What is the ratio of the Employment to population ratio(%) in Lao PDR in 2001 to that in 2005?
Give a very brief answer. 1.01. What is the ratio of the Employment to population ratio(%) in Swaziland in 2001 to that in 2005?
Provide a short and direct response. 1.01. What is the ratio of the Employment to population ratio(%) in Lao PDR in 2002 to that in 2003?
Keep it short and to the point. 1.01. What is the ratio of the Employment to population ratio(%) of Swaziland in 2002 to that in 2003?
Provide a succinct answer. 1. What is the ratio of the Employment to population ratio(%) of Cabo Verde in 2002 to that in 2004?
Your answer should be very brief. 1. What is the ratio of the Employment to population ratio(%) in Guyana in 2002 to that in 2004?
Provide a succinct answer. 1. What is the ratio of the Employment to population ratio(%) in Lao PDR in 2002 to that in 2004?
Keep it short and to the point. 1.02. What is the ratio of the Employment to population ratio(%) of Swaziland in 2002 to that in 2004?
Provide a short and direct response. 1.01. What is the ratio of the Employment to population ratio(%) of Cabo Verde in 2002 to that in 2005?
Provide a short and direct response. 1. What is the ratio of the Employment to population ratio(%) of Lao PDR in 2002 to that in 2005?
Keep it short and to the point. 1.01. What is the ratio of the Employment to population ratio(%) in Swaziland in 2002 to that in 2005?
Your answer should be very brief. 1.01. What is the ratio of the Employment to population ratio(%) of Cabo Verde in 2003 to that in 2004?
Keep it short and to the point. 1. What is the ratio of the Employment to population ratio(%) in Guyana in 2003 to that in 2004?
Offer a very short reply. 0.99. What is the ratio of the Employment to population ratio(%) in Lao PDR in 2003 to that in 2004?
Give a very brief answer. 1.01. What is the ratio of the Employment to population ratio(%) in Cabo Verde in 2003 to that in 2005?
Ensure brevity in your answer.  1. What is the ratio of the Employment to population ratio(%) in Swaziland in 2003 to that in 2005?
Ensure brevity in your answer.  1.01. What is the ratio of the Employment to population ratio(%) of Cabo Verde in 2004 to that in 2005?
Make the answer very short. 1. What is the ratio of the Employment to population ratio(%) in Guyana in 2004 to that in 2005?
Provide a short and direct response. 1.01. What is the ratio of the Employment to population ratio(%) of Swaziland in 2004 to that in 2005?
Provide a short and direct response. 1. What is the difference between the highest and the second highest Employment to population ratio(%) of Guyana?
Offer a very short reply. 0.2. What is the difference between the highest and the second highest Employment to population ratio(%) in Lao PDR?
Make the answer very short. 0.2. What is the difference between the highest and the lowest Employment to population ratio(%) of Lao PDR?
Your answer should be very brief. 2.1. 